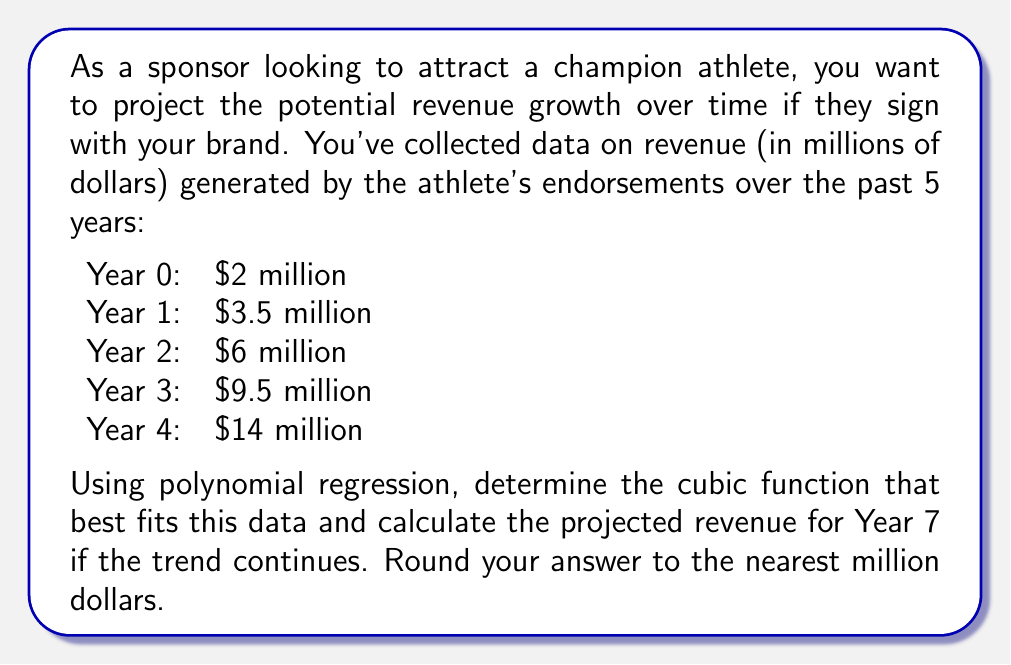What is the answer to this math problem? To solve this problem, we'll use cubic polynomial regression to fit a function of the form $f(x) = ax^3 + bx^2 + cx + d$ to the given data points.

1. Set up the system of equations:
   $$\begin{cases}
   a(0)^3 + b(0)^2 + c(0) + d = 2 \\
   a(1)^3 + b(1)^2 + c(1) + d = 3.5 \\
   a(2)^3 + b(2)^2 + c(2) + d = 6 \\
   a(3)^3 + b(3)^2 + c(3) + d = 9.5 \\
   a(4)^3 + b(4)^2 + c(4) + d = 14
   \end{cases}$$

2. Simplify:
   $$\begin{cases}
   d = 2 \\
   a + b + c + d = 3.5 \\
   8a + 4b + 2c + d = 6 \\
   27a + 9b + 3c + d = 9.5 \\
   64a + 16b + 4c + d = 14
   \end{cases}$$

3. Solve this system of equations (using a calculator or computer algebra system):
   $$\begin{aligned}
   a &\approx 0.0417 \\
   b &\approx 0.1250 \\
   c &\approx 1.2917 \\
   d &= 2
   \end{aligned}$$

4. The cubic function that best fits the data is:
   $$f(x) \approx 0.0417x^3 + 0.1250x^2 + 1.2917x + 2$$

5. To project the revenue for Year 7, evaluate $f(7)$:
   $$\begin{aligned}
   f(7) &\approx 0.0417(7^3) + 0.1250(7^2) + 1.2917(7) + 2 \\
   &\approx 14.3479 + 6.1250 + 9.0419 + 2 \\
   &\approx 31.5148
   \end{aligned}$$

6. Rounding to the nearest million dollars: $31.5148 \approx 32$ million dollars.
Answer: $32 million 